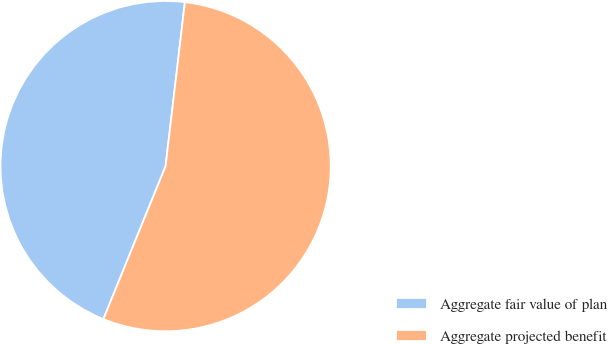Convert chart. <chart><loc_0><loc_0><loc_500><loc_500><pie_chart><fcel>Aggregate fair value of plan<fcel>Aggregate projected benefit<nl><fcel>45.72%<fcel>54.28%<nl></chart> 